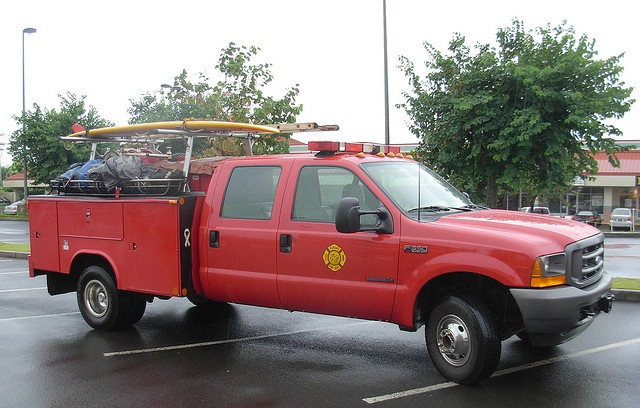Describe the objects in this image and their specific colors. I can see truck in white, brown, black, and gray tones, surfboard in white, gray, tan, and ivory tones, car in white, darkgray, gray, lightgray, and black tones, car in white, gray, darkgray, brown, and black tones, and car in white, darkgray, lightgray, gray, and lightblue tones in this image. 